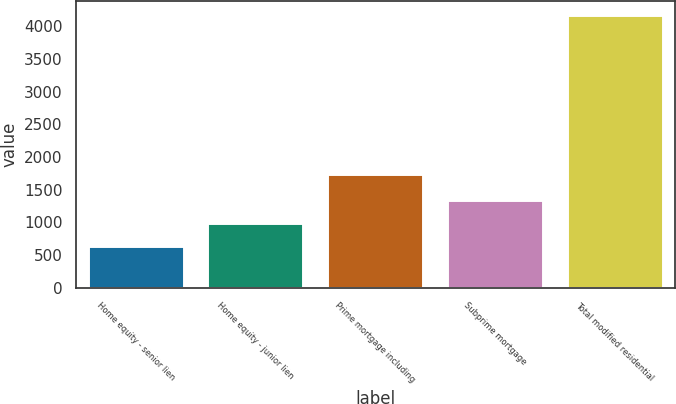Convert chart. <chart><loc_0><loc_0><loc_500><loc_500><bar_chart><fcel>Home equity - senior lien<fcel>Home equity - junior lien<fcel>Prime mortgage including<fcel>Subprime mortgage<fcel>Total modified residential<nl><fcel>641<fcel>994<fcel>1737<fcel>1347<fcel>4171<nl></chart> 